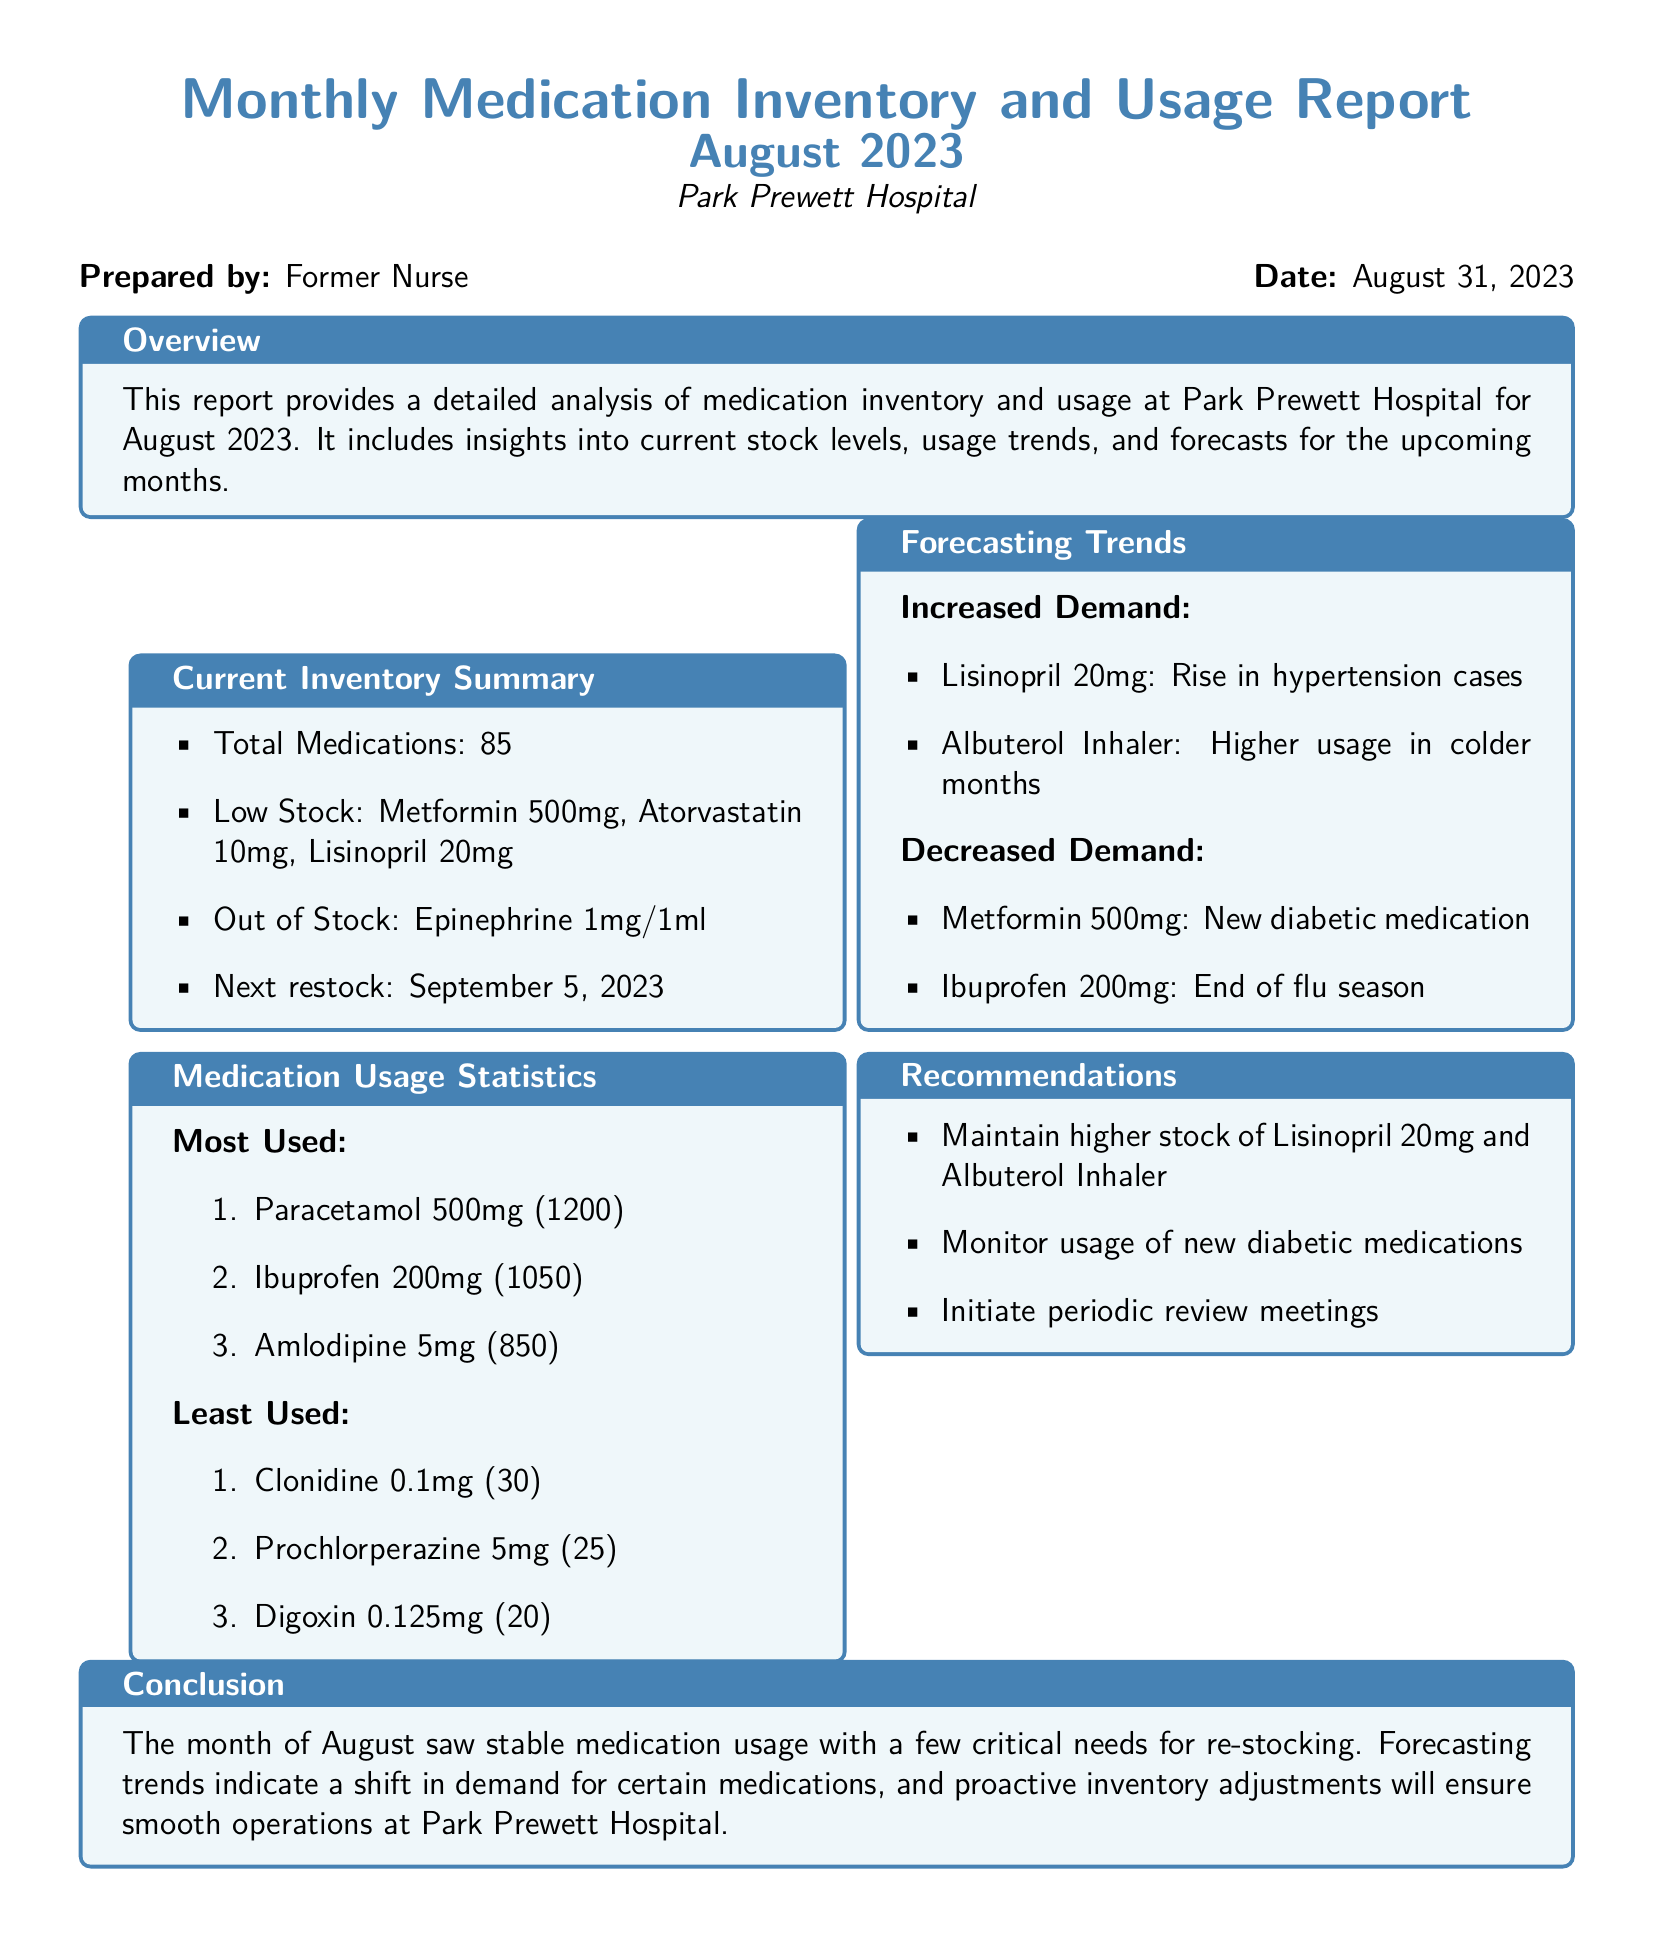What is the total number of medications? The total number of medications is listed in the current inventory summary section of the document.
Answer: 85 What are the low stock medications? The low stock medications can be found in the current inventory summary section, where specific medications are mentioned.
Answer: Metformin 500mg, Atorvastatin 10mg, Lisinopril 20mg Which medication is out of stock? The document specifies which medication is out of stock in the current inventory summary section.
Answer: Epinephrine 1mg/1ml What are the most used medications? The most used medications are listed in the medication usage statistics section of the report.
Answer: Paracetamol 500mg, Ibuprofen 200mg, Amlodipine 5mg What is the next restock date? The next restock date is provided in the current inventory summary section of the report.
Answer: September 5, 2023 What is expected to increase demand? The forecast section discusses medications expected to see increased demand.
Answer: Lisinopril 20mg, Albuterol Inhaler What is the reason for the increased demand for Lisinopril? The document states specific reasons for increased demand in the forecasting trends section.
Answer: Rise in hypertension cases What is recommended for stock levels? Recommendations for stock levels are provided in the recommendations section of the document.
Answer: Maintain higher stock of Lisinopril 20mg and Albuterol Inhaler What does the conclusion say about August's medication usage? The conclusion summarizes the situation regarding medication usage for the month.
Answer: Stable medication usage with a few critical needs for re-stocking 